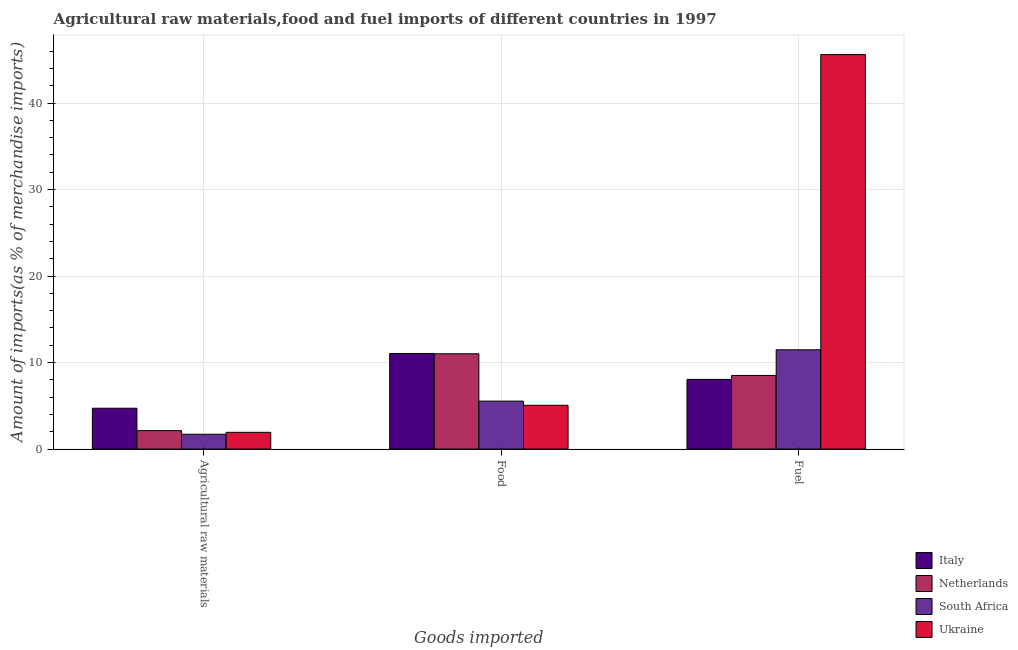Are the number of bars per tick equal to the number of legend labels?
Give a very brief answer. Yes. Are the number of bars on each tick of the X-axis equal?
Provide a short and direct response. Yes. How many bars are there on the 3rd tick from the left?
Provide a short and direct response. 4. What is the label of the 1st group of bars from the left?
Your answer should be very brief. Agricultural raw materials. What is the percentage of raw materials imports in Netherlands?
Your response must be concise. 2.13. Across all countries, what is the maximum percentage of food imports?
Keep it short and to the point. 11.05. Across all countries, what is the minimum percentage of raw materials imports?
Your answer should be very brief. 1.71. In which country was the percentage of raw materials imports maximum?
Offer a terse response. Italy. In which country was the percentage of fuel imports minimum?
Offer a very short reply. Italy. What is the total percentage of fuel imports in the graph?
Provide a succinct answer. 73.65. What is the difference between the percentage of raw materials imports in Ukraine and that in South Africa?
Make the answer very short. 0.22. What is the difference between the percentage of raw materials imports in Ukraine and the percentage of fuel imports in South Africa?
Provide a short and direct response. -9.54. What is the average percentage of food imports per country?
Provide a short and direct response. 8.17. What is the difference between the percentage of raw materials imports and percentage of fuel imports in South Africa?
Provide a short and direct response. -9.77. What is the ratio of the percentage of food imports in South Africa to that in Ukraine?
Your response must be concise. 1.1. What is the difference between the highest and the second highest percentage of food imports?
Provide a succinct answer. 0.04. What is the difference between the highest and the lowest percentage of fuel imports?
Give a very brief answer. 37.55. In how many countries, is the percentage of raw materials imports greater than the average percentage of raw materials imports taken over all countries?
Keep it short and to the point. 1. Is the sum of the percentage of food imports in Netherlands and Italy greater than the maximum percentage of fuel imports across all countries?
Your answer should be compact. No. What does the 4th bar from the left in Agricultural raw materials represents?
Provide a short and direct response. Ukraine. What does the 1st bar from the right in Fuel represents?
Provide a succinct answer. Ukraine. What is the difference between two consecutive major ticks on the Y-axis?
Offer a very short reply. 10. Are the values on the major ticks of Y-axis written in scientific E-notation?
Your response must be concise. No. Does the graph contain any zero values?
Give a very brief answer. No. What is the title of the graph?
Provide a succinct answer. Agricultural raw materials,food and fuel imports of different countries in 1997. What is the label or title of the X-axis?
Give a very brief answer. Goods imported. What is the label or title of the Y-axis?
Your answer should be compact. Amount of imports(as % of merchandise imports). What is the Amount of imports(as % of merchandise imports) of Italy in Agricultural raw materials?
Your response must be concise. 4.72. What is the Amount of imports(as % of merchandise imports) of Netherlands in Agricultural raw materials?
Your answer should be very brief. 2.13. What is the Amount of imports(as % of merchandise imports) of South Africa in Agricultural raw materials?
Your answer should be compact. 1.71. What is the Amount of imports(as % of merchandise imports) of Ukraine in Agricultural raw materials?
Give a very brief answer. 1.94. What is the Amount of imports(as % of merchandise imports) of Italy in Food?
Make the answer very short. 11.05. What is the Amount of imports(as % of merchandise imports) in Netherlands in Food?
Provide a short and direct response. 11.01. What is the Amount of imports(as % of merchandise imports) in South Africa in Food?
Give a very brief answer. 5.54. What is the Amount of imports(as % of merchandise imports) of Ukraine in Food?
Your answer should be very brief. 5.06. What is the Amount of imports(as % of merchandise imports) in Italy in Fuel?
Offer a very short reply. 8.05. What is the Amount of imports(as % of merchandise imports) in Netherlands in Fuel?
Offer a terse response. 8.51. What is the Amount of imports(as % of merchandise imports) in South Africa in Fuel?
Offer a terse response. 11.48. What is the Amount of imports(as % of merchandise imports) of Ukraine in Fuel?
Ensure brevity in your answer.  45.6. Across all Goods imported, what is the maximum Amount of imports(as % of merchandise imports) of Italy?
Provide a succinct answer. 11.05. Across all Goods imported, what is the maximum Amount of imports(as % of merchandise imports) in Netherlands?
Offer a very short reply. 11.01. Across all Goods imported, what is the maximum Amount of imports(as % of merchandise imports) in South Africa?
Offer a terse response. 11.48. Across all Goods imported, what is the maximum Amount of imports(as % of merchandise imports) in Ukraine?
Offer a very short reply. 45.6. Across all Goods imported, what is the minimum Amount of imports(as % of merchandise imports) in Italy?
Give a very brief answer. 4.72. Across all Goods imported, what is the minimum Amount of imports(as % of merchandise imports) in Netherlands?
Your response must be concise. 2.13. Across all Goods imported, what is the minimum Amount of imports(as % of merchandise imports) of South Africa?
Your answer should be very brief. 1.71. Across all Goods imported, what is the minimum Amount of imports(as % of merchandise imports) in Ukraine?
Give a very brief answer. 1.94. What is the total Amount of imports(as % of merchandise imports) in Italy in the graph?
Keep it short and to the point. 23.83. What is the total Amount of imports(as % of merchandise imports) of Netherlands in the graph?
Make the answer very short. 21.66. What is the total Amount of imports(as % of merchandise imports) of South Africa in the graph?
Keep it short and to the point. 18.74. What is the total Amount of imports(as % of merchandise imports) of Ukraine in the graph?
Provide a succinct answer. 52.6. What is the difference between the Amount of imports(as % of merchandise imports) of Italy in Agricultural raw materials and that in Food?
Ensure brevity in your answer.  -6.33. What is the difference between the Amount of imports(as % of merchandise imports) of Netherlands in Agricultural raw materials and that in Food?
Your answer should be very brief. -8.88. What is the difference between the Amount of imports(as % of merchandise imports) of South Africa in Agricultural raw materials and that in Food?
Offer a very short reply. -3.83. What is the difference between the Amount of imports(as % of merchandise imports) of Ukraine in Agricultural raw materials and that in Food?
Give a very brief answer. -3.12. What is the difference between the Amount of imports(as % of merchandise imports) in Italy in Agricultural raw materials and that in Fuel?
Your response must be concise. -3.33. What is the difference between the Amount of imports(as % of merchandise imports) of Netherlands in Agricultural raw materials and that in Fuel?
Offer a very short reply. -6.38. What is the difference between the Amount of imports(as % of merchandise imports) of South Africa in Agricultural raw materials and that in Fuel?
Ensure brevity in your answer.  -9.77. What is the difference between the Amount of imports(as % of merchandise imports) of Ukraine in Agricultural raw materials and that in Fuel?
Your answer should be very brief. -43.66. What is the difference between the Amount of imports(as % of merchandise imports) in Italy in Food and that in Fuel?
Provide a succinct answer. 3. What is the difference between the Amount of imports(as % of merchandise imports) of Netherlands in Food and that in Fuel?
Offer a very short reply. 2.5. What is the difference between the Amount of imports(as % of merchandise imports) of South Africa in Food and that in Fuel?
Ensure brevity in your answer.  -5.93. What is the difference between the Amount of imports(as % of merchandise imports) in Ukraine in Food and that in Fuel?
Ensure brevity in your answer.  -40.54. What is the difference between the Amount of imports(as % of merchandise imports) of Italy in Agricultural raw materials and the Amount of imports(as % of merchandise imports) of Netherlands in Food?
Your answer should be compact. -6.29. What is the difference between the Amount of imports(as % of merchandise imports) of Italy in Agricultural raw materials and the Amount of imports(as % of merchandise imports) of South Africa in Food?
Your response must be concise. -0.82. What is the difference between the Amount of imports(as % of merchandise imports) of Italy in Agricultural raw materials and the Amount of imports(as % of merchandise imports) of Ukraine in Food?
Make the answer very short. -0.34. What is the difference between the Amount of imports(as % of merchandise imports) of Netherlands in Agricultural raw materials and the Amount of imports(as % of merchandise imports) of South Africa in Food?
Give a very brief answer. -3.41. What is the difference between the Amount of imports(as % of merchandise imports) of Netherlands in Agricultural raw materials and the Amount of imports(as % of merchandise imports) of Ukraine in Food?
Offer a terse response. -2.93. What is the difference between the Amount of imports(as % of merchandise imports) in South Africa in Agricultural raw materials and the Amount of imports(as % of merchandise imports) in Ukraine in Food?
Provide a short and direct response. -3.35. What is the difference between the Amount of imports(as % of merchandise imports) of Italy in Agricultural raw materials and the Amount of imports(as % of merchandise imports) of Netherlands in Fuel?
Keep it short and to the point. -3.79. What is the difference between the Amount of imports(as % of merchandise imports) in Italy in Agricultural raw materials and the Amount of imports(as % of merchandise imports) in South Africa in Fuel?
Provide a short and direct response. -6.75. What is the difference between the Amount of imports(as % of merchandise imports) of Italy in Agricultural raw materials and the Amount of imports(as % of merchandise imports) of Ukraine in Fuel?
Your response must be concise. -40.88. What is the difference between the Amount of imports(as % of merchandise imports) in Netherlands in Agricultural raw materials and the Amount of imports(as % of merchandise imports) in South Africa in Fuel?
Provide a succinct answer. -9.35. What is the difference between the Amount of imports(as % of merchandise imports) of Netherlands in Agricultural raw materials and the Amount of imports(as % of merchandise imports) of Ukraine in Fuel?
Your answer should be very brief. -43.47. What is the difference between the Amount of imports(as % of merchandise imports) in South Africa in Agricultural raw materials and the Amount of imports(as % of merchandise imports) in Ukraine in Fuel?
Your answer should be very brief. -43.89. What is the difference between the Amount of imports(as % of merchandise imports) of Italy in Food and the Amount of imports(as % of merchandise imports) of Netherlands in Fuel?
Give a very brief answer. 2.54. What is the difference between the Amount of imports(as % of merchandise imports) of Italy in Food and the Amount of imports(as % of merchandise imports) of South Africa in Fuel?
Provide a succinct answer. -0.43. What is the difference between the Amount of imports(as % of merchandise imports) of Italy in Food and the Amount of imports(as % of merchandise imports) of Ukraine in Fuel?
Your response must be concise. -34.55. What is the difference between the Amount of imports(as % of merchandise imports) of Netherlands in Food and the Amount of imports(as % of merchandise imports) of South Africa in Fuel?
Your answer should be compact. -0.46. What is the difference between the Amount of imports(as % of merchandise imports) in Netherlands in Food and the Amount of imports(as % of merchandise imports) in Ukraine in Fuel?
Provide a short and direct response. -34.59. What is the difference between the Amount of imports(as % of merchandise imports) in South Africa in Food and the Amount of imports(as % of merchandise imports) in Ukraine in Fuel?
Your answer should be compact. -40.06. What is the average Amount of imports(as % of merchandise imports) in Italy per Goods imported?
Make the answer very short. 7.94. What is the average Amount of imports(as % of merchandise imports) of Netherlands per Goods imported?
Provide a short and direct response. 7.22. What is the average Amount of imports(as % of merchandise imports) of South Africa per Goods imported?
Offer a terse response. 6.25. What is the average Amount of imports(as % of merchandise imports) of Ukraine per Goods imported?
Offer a very short reply. 17.53. What is the difference between the Amount of imports(as % of merchandise imports) of Italy and Amount of imports(as % of merchandise imports) of Netherlands in Agricultural raw materials?
Your response must be concise. 2.59. What is the difference between the Amount of imports(as % of merchandise imports) of Italy and Amount of imports(as % of merchandise imports) of South Africa in Agricultural raw materials?
Your answer should be very brief. 3.01. What is the difference between the Amount of imports(as % of merchandise imports) of Italy and Amount of imports(as % of merchandise imports) of Ukraine in Agricultural raw materials?
Offer a very short reply. 2.79. What is the difference between the Amount of imports(as % of merchandise imports) of Netherlands and Amount of imports(as % of merchandise imports) of South Africa in Agricultural raw materials?
Your answer should be compact. 0.42. What is the difference between the Amount of imports(as % of merchandise imports) in Netherlands and Amount of imports(as % of merchandise imports) in Ukraine in Agricultural raw materials?
Your response must be concise. 0.2. What is the difference between the Amount of imports(as % of merchandise imports) in South Africa and Amount of imports(as % of merchandise imports) in Ukraine in Agricultural raw materials?
Keep it short and to the point. -0.22. What is the difference between the Amount of imports(as % of merchandise imports) in Italy and Amount of imports(as % of merchandise imports) in Netherlands in Food?
Your answer should be very brief. 0.04. What is the difference between the Amount of imports(as % of merchandise imports) of Italy and Amount of imports(as % of merchandise imports) of South Africa in Food?
Offer a very short reply. 5.51. What is the difference between the Amount of imports(as % of merchandise imports) in Italy and Amount of imports(as % of merchandise imports) in Ukraine in Food?
Offer a very short reply. 5.99. What is the difference between the Amount of imports(as % of merchandise imports) in Netherlands and Amount of imports(as % of merchandise imports) in South Africa in Food?
Your response must be concise. 5.47. What is the difference between the Amount of imports(as % of merchandise imports) of Netherlands and Amount of imports(as % of merchandise imports) of Ukraine in Food?
Keep it short and to the point. 5.95. What is the difference between the Amount of imports(as % of merchandise imports) of South Africa and Amount of imports(as % of merchandise imports) of Ukraine in Food?
Provide a short and direct response. 0.48. What is the difference between the Amount of imports(as % of merchandise imports) of Italy and Amount of imports(as % of merchandise imports) of Netherlands in Fuel?
Your answer should be very brief. -0.46. What is the difference between the Amount of imports(as % of merchandise imports) in Italy and Amount of imports(as % of merchandise imports) in South Africa in Fuel?
Offer a very short reply. -3.42. What is the difference between the Amount of imports(as % of merchandise imports) of Italy and Amount of imports(as % of merchandise imports) of Ukraine in Fuel?
Keep it short and to the point. -37.55. What is the difference between the Amount of imports(as % of merchandise imports) of Netherlands and Amount of imports(as % of merchandise imports) of South Africa in Fuel?
Offer a terse response. -2.97. What is the difference between the Amount of imports(as % of merchandise imports) of Netherlands and Amount of imports(as % of merchandise imports) of Ukraine in Fuel?
Provide a short and direct response. -37.09. What is the difference between the Amount of imports(as % of merchandise imports) in South Africa and Amount of imports(as % of merchandise imports) in Ukraine in Fuel?
Give a very brief answer. -34.12. What is the ratio of the Amount of imports(as % of merchandise imports) in Italy in Agricultural raw materials to that in Food?
Offer a very short reply. 0.43. What is the ratio of the Amount of imports(as % of merchandise imports) in Netherlands in Agricultural raw materials to that in Food?
Ensure brevity in your answer.  0.19. What is the ratio of the Amount of imports(as % of merchandise imports) of South Africa in Agricultural raw materials to that in Food?
Your answer should be compact. 0.31. What is the ratio of the Amount of imports(as % of merchandise imports) of Ukraine in Agricultural raw materials to that in Food?
Your answer should be compact. 0.38. What is the ratio of the Amount of imports(as % of merchandise imports) of Italy in Agricultural raw materials to that in Fuel?
Offer a very short reply. 0.59. What is the ratio of the Amount of imports(as % of merchandise imports) of Netherlands in Agricultural raw materials to that in Fuel?
Your answer should be very brief. 0.25. What is the ratio of the Amount of imports(as % of merchandise imports) in South Africa in Agricultural raw materials to that in Fuel?
Offer a very short reply. 0.15. What is the ratio of the Amount of imports(as % of merchandise imports) in Ukraine in Agricultural raw materials to that in Fuel?
Provide a short and direct response. 0.04. What is the ratio of the Amount of imports(as % of merchandise imports) of Italy in Food to that in Fuel?
Your answer should be compact. 1.37. What is the ratio of the Amount of imports(as % of merchandise imports) in Netherlands in Food to that in Fuel?
Offer a terse response. 1.29. What is the ratio of the Amount of imports(as % of merchandise imports) of South Africa in Food to that in Fuel?
Your response must be concise. 0.48. What is the ratio of the Amount of imports(as % of merchandise imports) of Ukraine in Food to that in Fuel?
Offer a very short reply. 0.11. What is the difference between the highest and the second highest Amount of imports(as % of merchandise imports) in Italy?
Provide a short and direct response. 3. What is the difference between the highest and the second highest Amount of imports(as % of merchandise imports) in Netherlands?
Your answer should be compact. 2.5. What is the difference between the highest and the second highest Amount of imports(as % of merchandise imports) in South Africa?
Ensure brevity in your answer.  5.93. What is the difference between the highest and the second highest Amount of imports(as % of merchandise imports) in Ukraine?
Provide a succinct answer. 40.54. What is the difference between the highest and the lowest Amount of imports(as % of merchandise imports) of Italy?
Give a very brief answer. 6.33. What is the difference between the highest and the lowest Amount of imports(as % of merchandise imports) in Netherlands?
Make the answer very short. 8.88. What is the difference between the highest and the lowest Amount of imports(as % of merchandise imports) in South Africa?
Ensure brevity in your answer.  9.77. What is the difference between the highest and the lowest Amount of imports(as % of merchandise imports) of Ukraine?
Your answer should be compact. 43.66. 